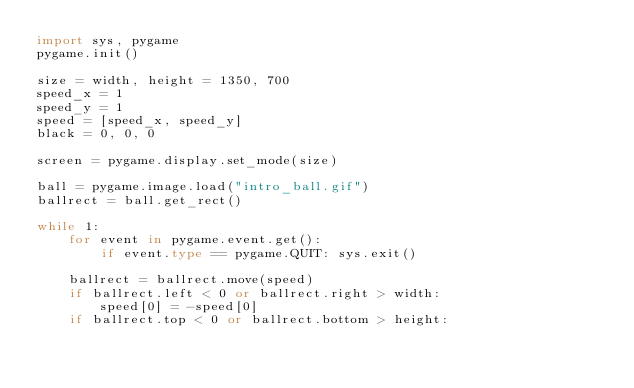Convert code to text. <code><loc_0><loc_0><loc_500><loc_500><_Python_>import sys, pygame
pygame.init()

size = width, height = 1350, 700
speed_x = 1
speed_y = 1
speed = [speed_x, speed_y]
black = 0, 0, 0

screen = pygame.display.set_mode(size)

ball = pygame.image.load("intro_ball.gif")
ballrect = ball.get_rect()

while 1:
    for event in pygame.event.get():
        if event.type == pygame.QUIT: sys.exit()

    ballrect = ballrect.move(speed)
    if ballrect.left < 0 or ballrect.right > width:
        speed[0] = -speed[0]
    if ballrect.top < 0 or ballrect.bottom > height:</code> 